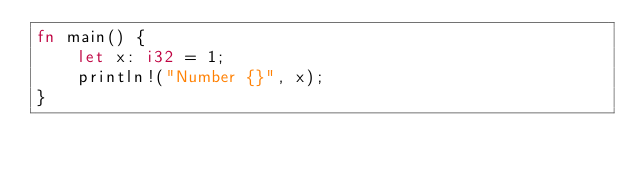Convert code to text. <code><loc_0><loc_0><loc_500><loc_500><_Rust_>fn main() {
    let x: i32 = 1;
    println!("Number {}", x);
}
</code> 